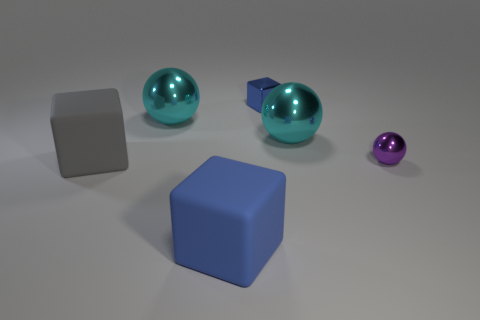Can you describe the arrangement of objects on the surface? Certainly! There are five objects arranged on the surface: two large cyan spheres aligned centrally, a grey cube on the left, a small purple sphere to the far right, and a blue rubber cube in front. They're spaced out evenly on a flat, dull surface that recedes into the background. 